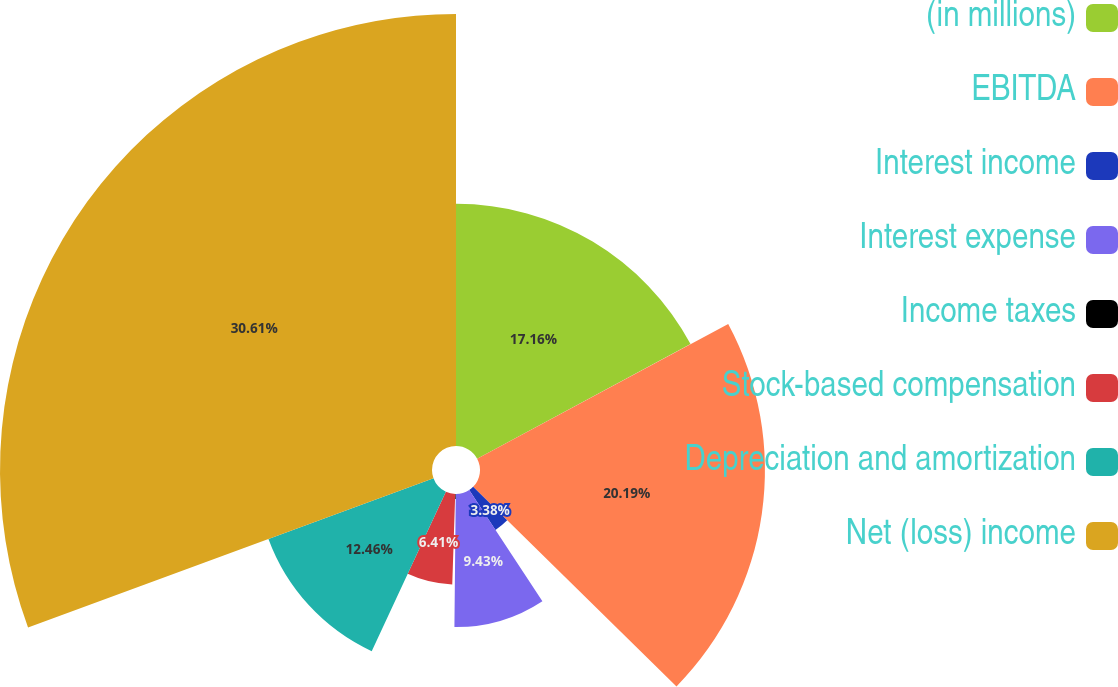Convert chart to OTSL. <chart><loc_0><loc_0><loc_500><loc_500><pie_chart><fcel>(in millions)<fcel>EBITDA<fcel>Interest income<fcel>Interest expense<fcel>Income taxes<fcel>Stock-based compensation<fcel>Depreciation and amortization<fcel>Net (loss) income<nl><fcel>17.16%<fcel>20.19%<fcel>3.38%<fcel>9.43%<fcel>0.36%<fcel>6.41%<fcel>12.46%<fcel>30.61%<nl></chart> 